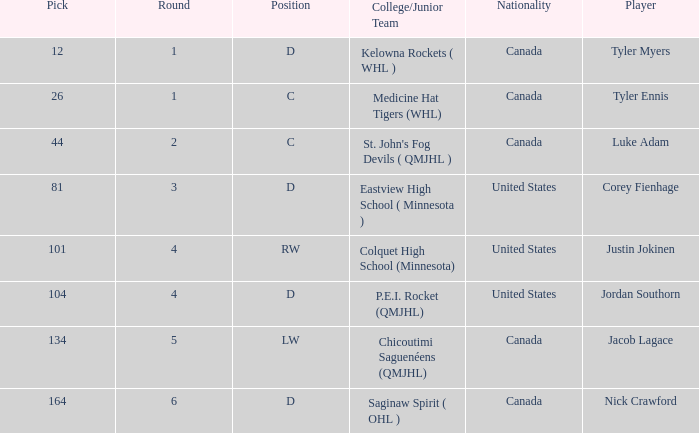Help me parse the entirety of this table. {'header': ['Pick', 'Round', 'Position', 'College/Junior Team', 'Nationality', 'Player'], 'rows': [['12', '1', 'D', 'Kelowna Rockets ( WHL )', 'Canada', 'Tyler Myers'], ['26', '1', 'C', 'Medicine Hat Tigers (WHL)', 'Canada', 'Tyler Ennis'], ['44', '2', 'C', "St. John's Fog Devils ( QMJHL )", 'Canada', 'Luke Adam'], ['81', '3', 'D', 'Eastview High School ( Minnesota )', 'United States', 'Corey Fienhage'], ['101', '4', 'RW', 'Colquet High School (Minnesota)', 'United States', 'Justin Jokinen'], ['104', '4', 'D', 'P.E.I. Rocket (QMJHL)', 'United States', 'Jordan Southorn'], ['134', '5', 'LW', 'Chicoutimi Saguenéens (QMJHL)', 'Canada', 'Jacob Lagace'], ['164', '6', 'D', 'Saginaw Spirit ( OHL )', 'Canada', 'Nick Crawford']]} What is the sum of the pick of the lw position player? 134.0. 